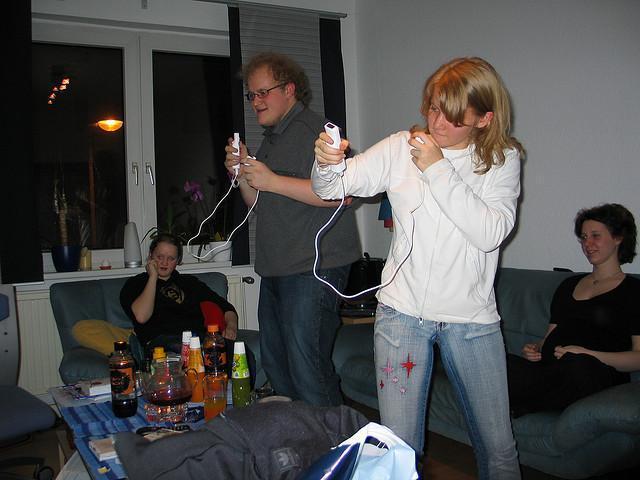How many people are visible?
Give a very brief answer. 4. How many couches can be seen?
Give a very brief answer. 2. 